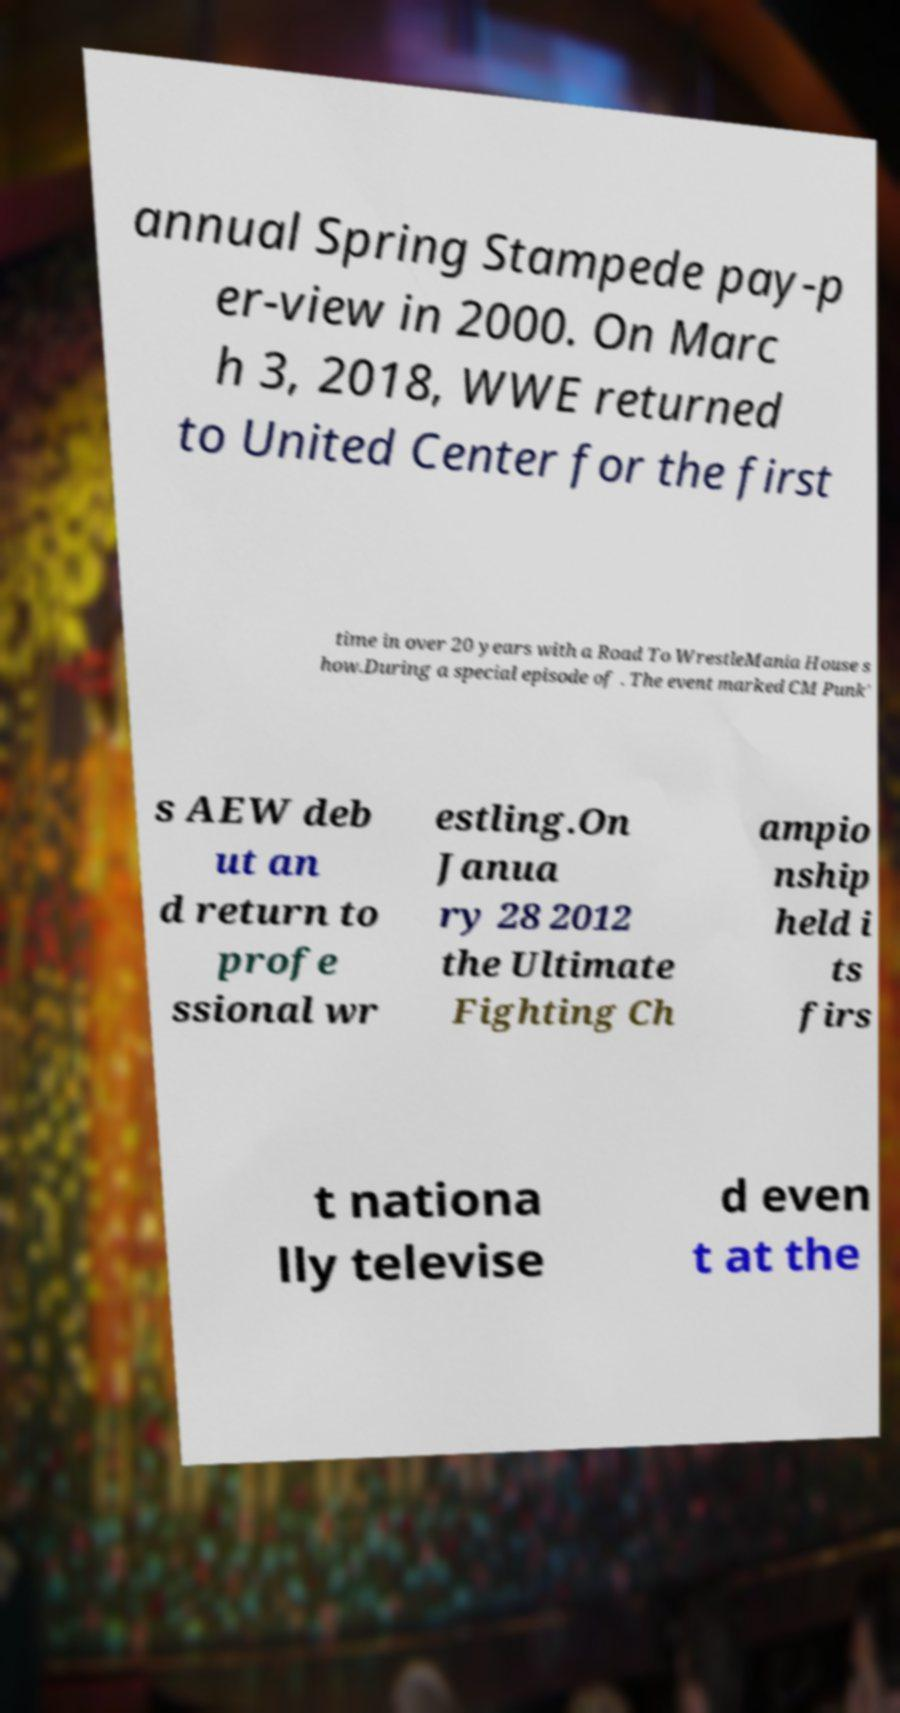Please read and relay the text visible in this image. What does it say? annual Spring Stampede pay-p er-view in 2000. On Marc h 3, 2018, WWE returned to United Center for the first time in over 20 years with a Road To WrestleMania House s how.During a special episode of . The event marked CM Punk' s AEW deb ut an d return to profe ssional wr estling.On Janua ry 28 2012 the Ultimate Fighting Ch ampio nship held i ts firs t nationa lly televise d even t at the 